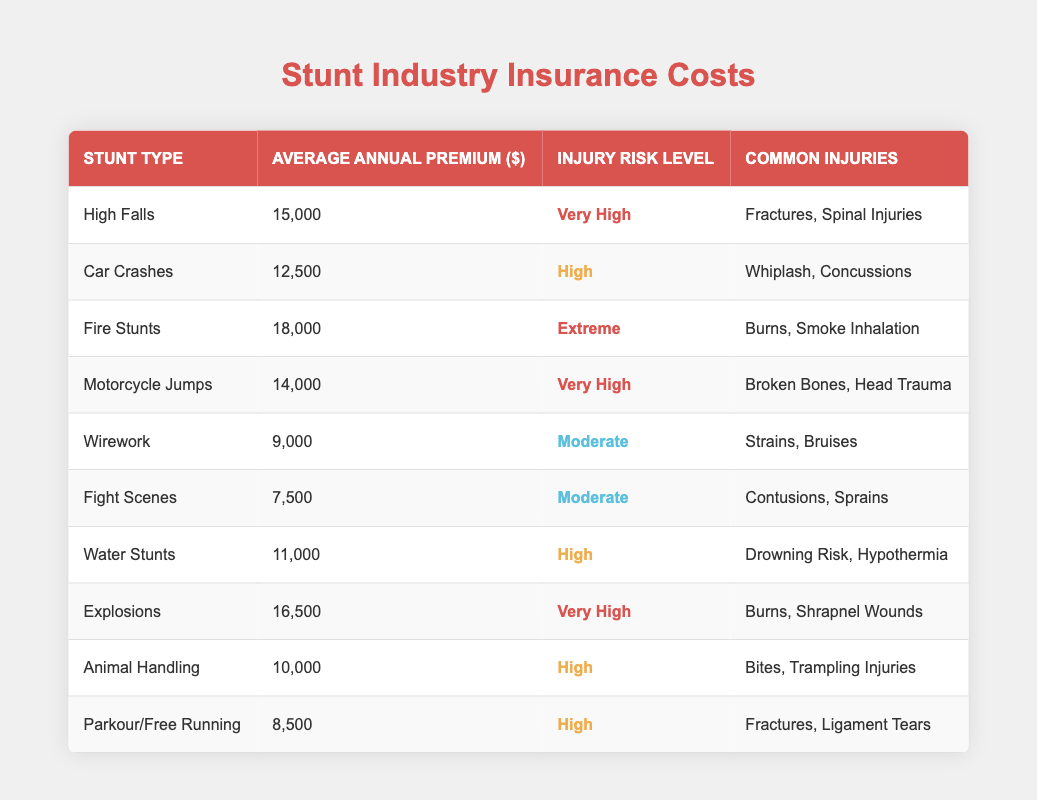What is the average annual premium for Fire Stunts? The table lists the average annual premium for Fire Stunts as 18,000.
Answer: 18,000 What are the common injuries associated with High Falls? According to the table, the common injuries for High Falls include fractures and spinal injuries.
Answer: Fractures, Spinal Injuries Which stunt type has the highest injury risk level? By examining the table, Fire Stunts are classified with an extreme injury risk level, which is the highest.
Answer: Fire Stunts What is the total average annual premium for Very High risk stunts? There are three stunt types with Very High risk levels: High Falls ($15,000), Motorcycle Jumps ($14,000), and Explosions ($16,500). Summing these values gives 15,000 + 14,000 + 16,500 = 45,500.
Answer: 45,500 Is the average annual premium for Animal Handling higher than that for Water Stunts? The average annual premium for Animal Handling is 10,000, while for Water Stunts it is 11,000. Thus, 10,000 is not higher than 11,000, making this statement false.
Answer: No What is the average annual premium for stunts categorized as Moderate? The Moderate stunt types are Wirework ($9,000) and Fight Scenes ($7,500). Adding those gives 9,000 + 7,500 = 16,500, and averaging by dividing by 2 results in 16,500 / 2 = 8,250.
Answer: 8,250 How many stunt types have a common injury risk level categorized as High? The table shows four stunts with a High risk level: Car Crashes, Water Stunts, Animal Handling, and Parkour/Free Running. This counts to a total of four stunt types.
Answer: 4 Which stunt type has the second-highest average annual premium? Looking at the premiums in descending order: Fire Stunts ($18,000), Explosions ($16,500), High Falls ($15,000). Therefore, the second highest is Explosions at $16,500.
Answer: Explosions What percentage of stunt types are categorized as Moderate? There are 10 total stunt types in the table, and 2 of these are Moderate (Wirework and Fight Scenes). Thus, the percentage is (2 / 10) * 100 = 20%.
Answer: 20% 